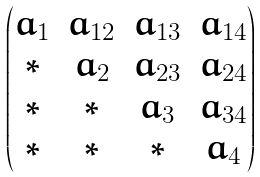<formula> <loc_0><loc_0><loc_500><loc_500>\begin{pmatrix} a _ { 1 } & a _ { 1 2 } & a _ { 1 3 } & a _ { 1 4 } \\ * & a _ { 2 } & a _ { 2 3 } & a _ { 2 4 } \\ * & * & a _ { 3 } & a _ { 3 4 } \\ * & * & * & a _ { 4 } \end{pmatrix}</formula> 